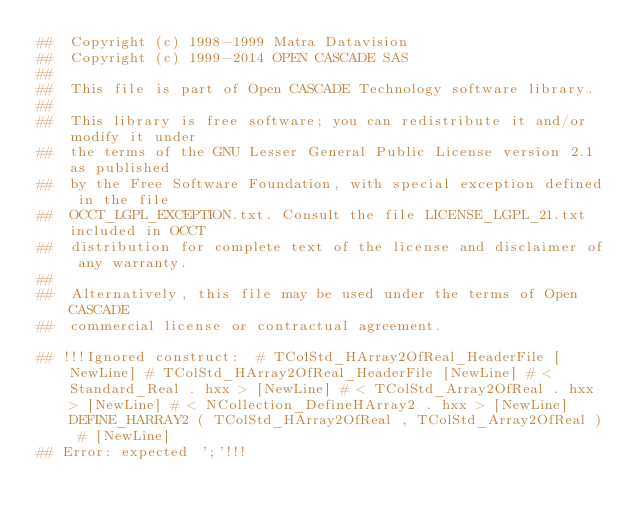Convert code to text. <code><loc_0><loc_0><loc_500><loc_500><_Nim_>##  Copyright (c) 1998-1999 Matra Datavision
##  Copyright (c) 1999-2014 OPEN CASCADE SAS
##
##  This file is part of Open CASCADE Technology software library.
##
##  This library is free software; you can redistribute it and/or modify it under
##  the terms of the GNU Lesser General Public License version 2.1 as published
##  by the Free Software Foundation, with special exception defined in the file
##  OCCT_LGPL_EXCEPTION.txt. Consult the file LICENSE_LGPL_21.txt included in OCCT
##  distribution for complete text of the license and disclaimer of any warranty.
##
##  Alternatively, this file may be used under the terms of Open CASCADE
##  commercial license or contractual agreement.

## !!!Ignored construct:  # TColStd_HArray2OfReal_HeaderFile [NewLine] # TColStd_HArray2OfReal_HeaderFile [NewLine] # < Standard_Real . hxx > [NewLine] # < TColStd_Array2OfReal . hxx > [NewLine] # < NCollection_DefineHArray2 . hxx > [NewLine] DEFINE_HARRAY2 ( TColStd_HArray2OfReal , TColStd_Array2OfReal ) # [NewLine]
## Error: expected ';'!!!















































</code> 